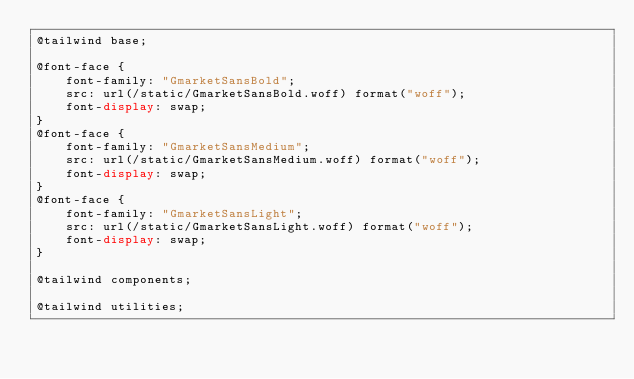<code> <loc_0><loc_0><loc_500><loc_500><_CSS_>@tailwind base;

@font-face {
	font-family: "GmarketSansBold";
	src: url(/static/GmarketSansBold.woff) format("woff");
	font-display: swap;
}
@font-face {
	font-family: "GmarketSansMedium";
	src: url(/static/GmarketSansMedium.woff) format("woff");
	font-display: swap;
}
@font-face {
	font-family: "GmarketSansLight";
	src: url(/static/GmarketSansLight.woff) format("woff");
	font-display: swap;
}

@tailwind components;

@tailwind utilities;
</code> 